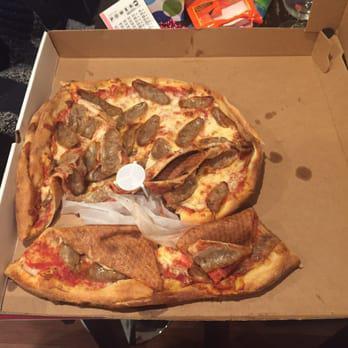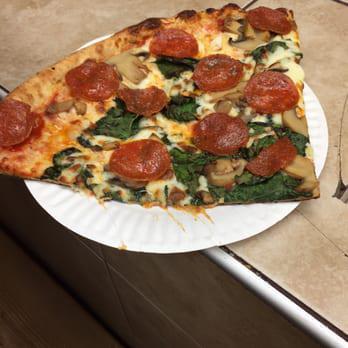The first image is the image on the left, the second image is the image on the right. Given the left and right images, does the statement "A whole pizza sits in a cardboard box in one of the images." hold true? Answer yes or no. Yes. The first image is the image on the left, the second image is the image on the right. Evaluate the accuracy of this statement regarding the images: "There is a single slice of pizza on a paper plate.". Is it true? Answer yes or no. Yes. 